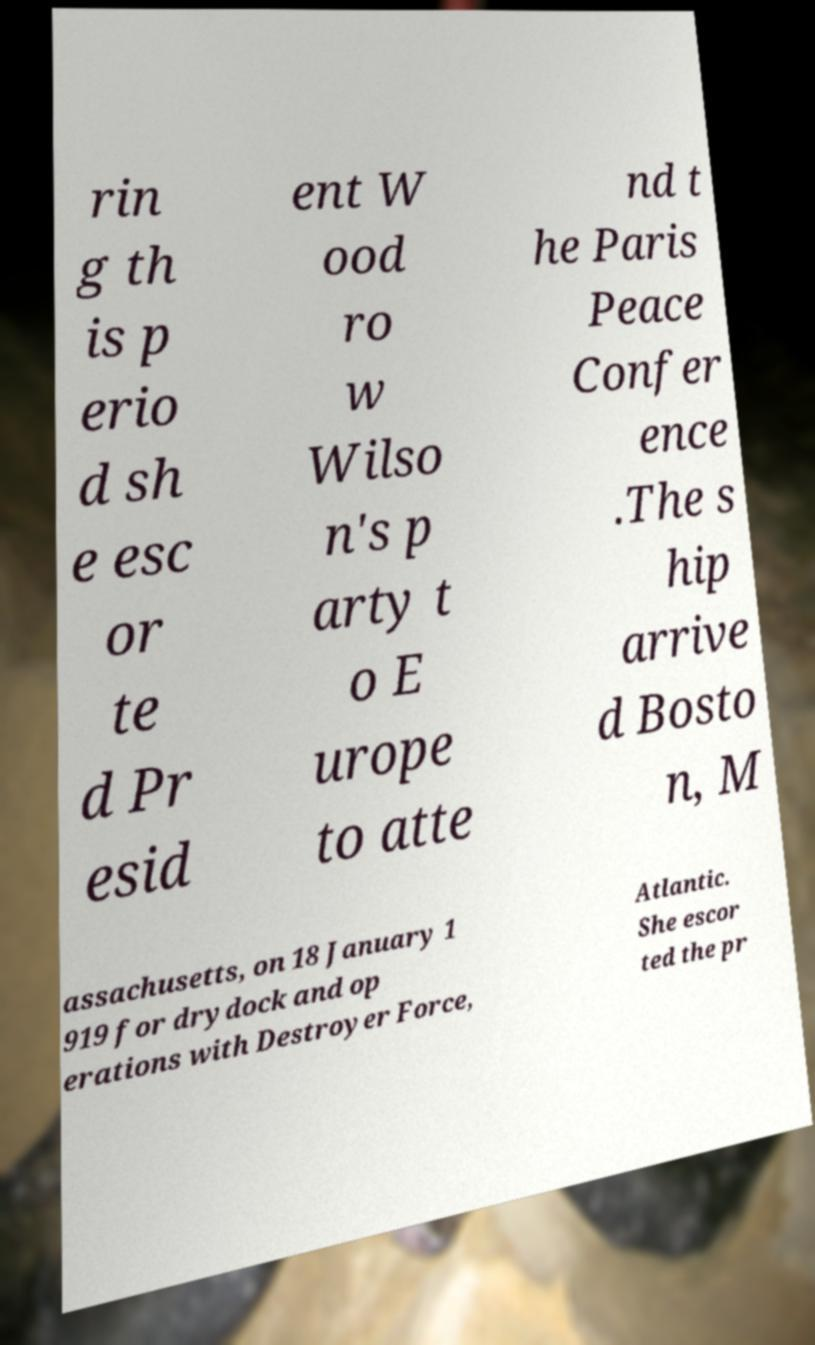What messages or text are displayed in this image? I need them in a readable, typed format. rin g th is p erio d sh e esc or te d Pr esid ent W ood ro w Wilso n's p arty t o E urope to atte nd t he Paris Peace Confer ence .The s hip arrive d Bosto n, M assachusetts, on 18 January 1 919 for drydock and op erations with Destroyer Force, Atlantic. She escor ted the pr 